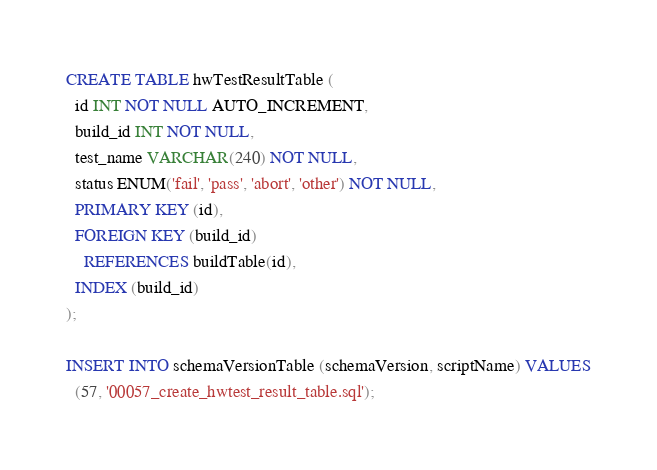<code> <loc_0><loc_0><loc_500><loc_500><_SQL_>CREATE TABLE hwTestResultTable (
  id INT NOT NULL AUTO_INCREMENT,
  build_id INT NOT NULL,
  test_name VARCHAR(240) NOT NULL,
  status ENUM('fail', 'pass', 'abort', 'other') NOT NULL,
  PRIMARY KEY (id),
  FOREIGN KEY (build_id)
    REFERENCES buildTable(id),
  INDEX (build_id)
);

INSERT INTO schemaVersionTable (schemaVersion, scriptName) VALUES
  (57, '00057_create_hwtest_result_table.sql');
</code> 